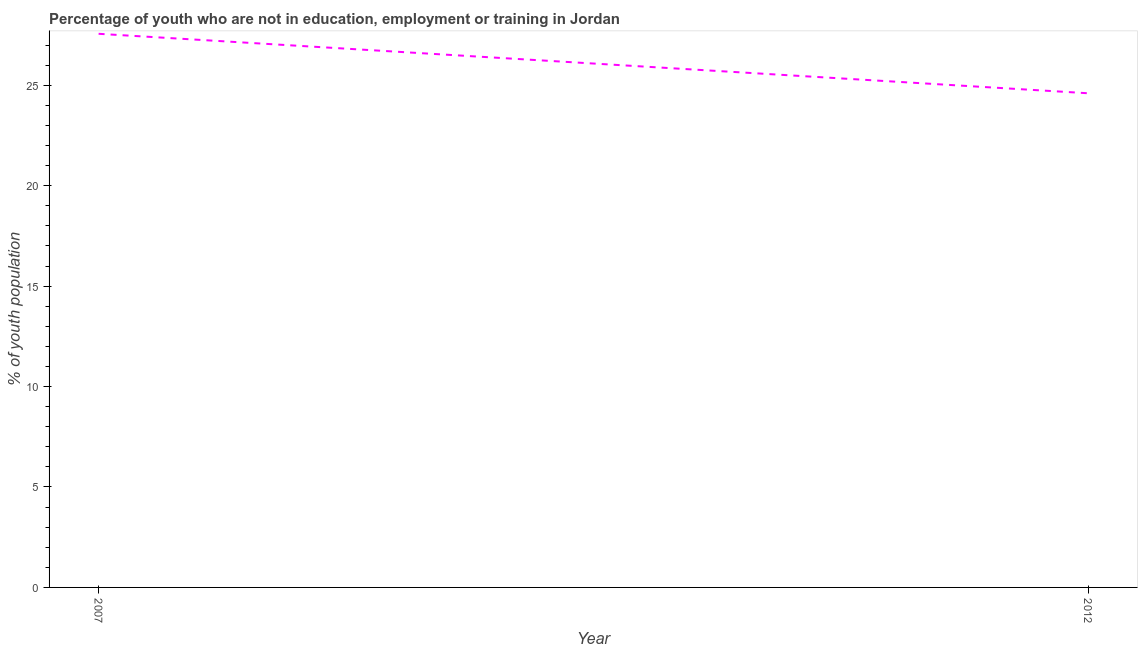What is the unemployed youth population in 2012?
Offer a very short reply. 24.6. Across all years, what is the maximum unemployed youth population?
Ensure brevity in your answer.  27.56. Across all years, what is the minimum unemployed youth population?
Your answer should be very brief. 24.6. What is the sum of the unemployed youth population?
Keep it short and to the point. 52.16. What is the difference between the unemployed youth population in 2007 and 2012?
Your answer should be compact. 2.96. What is the average unemployed youth population per year?
Keep it short and to the point. 26.08. What is the median unemployed youth population?
Offer a terse response. 26.08. Do a majority of the years between 2012 and 2007 (inclusive) have unemployed youth population greater than 12 %?
Ensure brevity in your answer.  No. What is the ratio of the unemployed youth population in 2007 to that in 2012?
Your answer should be compact. 1.12. Is the unemployed youth population in 2007 less than that in 2012?
Your response must be concise. No. Does the unemployed youth population monotonically increase over the years?
Your answer should be very brief. No. How many years are there in the graph?
Make the answer very short. 2. What is the difference between two consecutive major ticks on the Y-axis?
Your answer should be compact. 5. Are the values on the major ticks of Y-axis written in scientific E-notation?
Ensure brevity in your answer.  No. Does the graph contain grids?
Your answer should be very brief. No. What is the title of the graph?
Provide a succinct answer. Percentage of youth who are not in education, employment or training in Jordan. What is the label or title of the X-axis?
Make the answer very short. Year. What is the label or title of the Y-axis?
Provide a short and direct response. % of youth population. What is the % of youth population in 2007?
Keep it short and to the point. 27.56. What is the % of youth population in 2012?
Your answer should be very brief. 24.6. What is the difference between the % of youth population in 2007 and 2012?
Ensure brevity in your answer.  2.96. What is the ratio of the % of youth population in 2007 to that in 2012?
Ensure brevity in your answer.  1.12. 